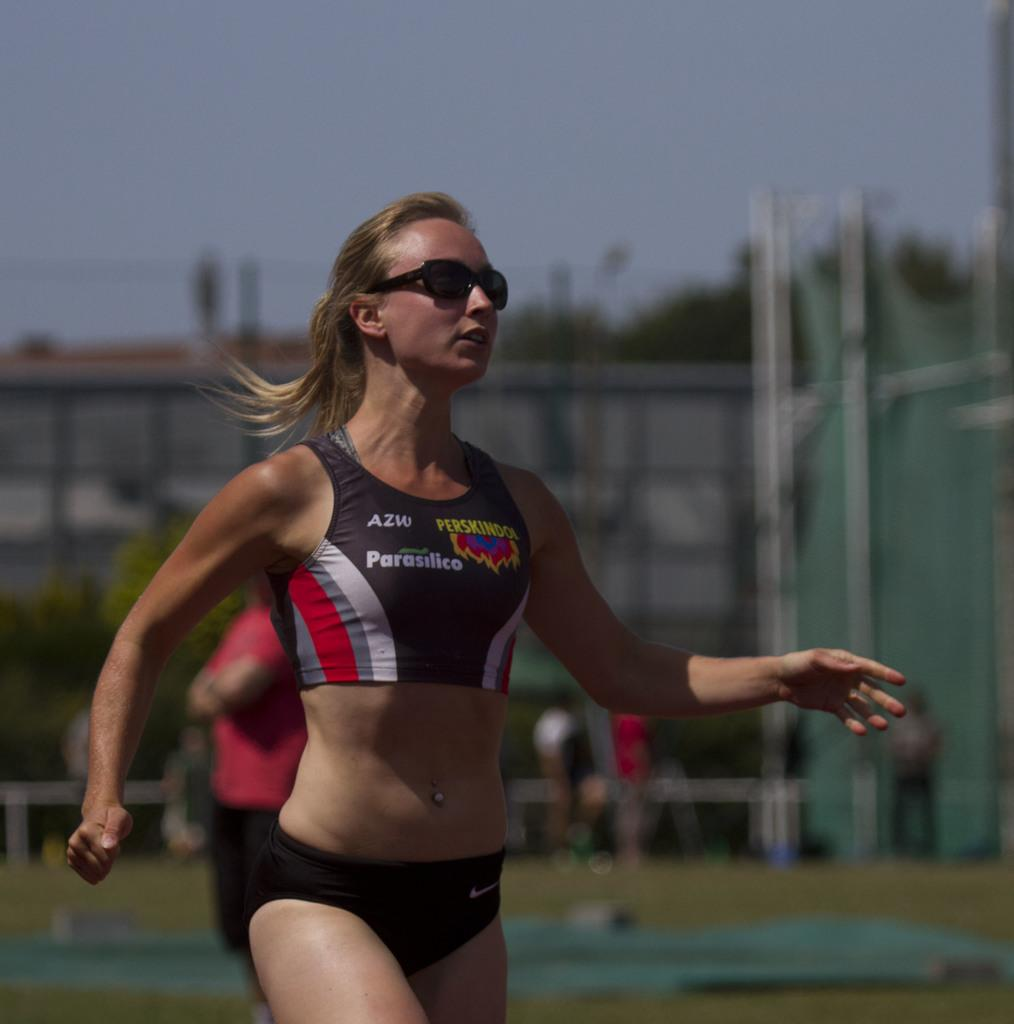<image>
Provide a brief description of the given image. A female runner wears a uniform bearing the name Parasilico. 